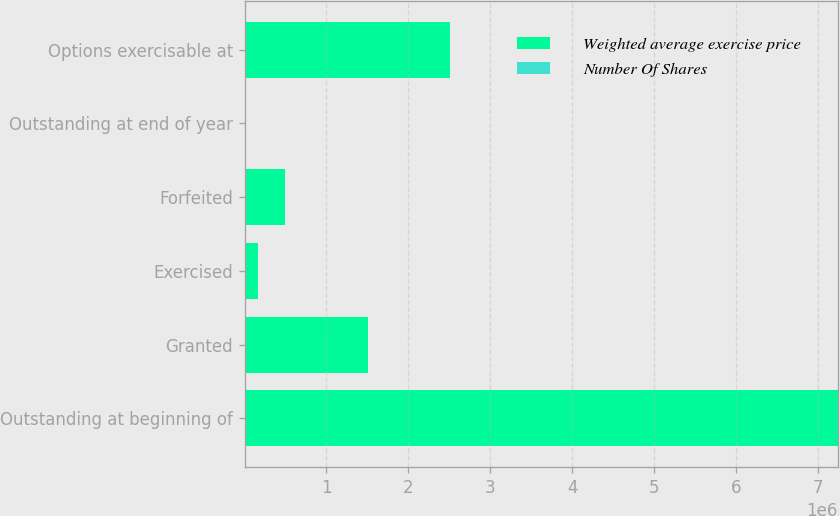Convert chart to OTSL. <chart><loc_0><loc_0><loc_500><loc_500><stacked_bar_chart><ecel><fcel>Outstanding at beginning of<fcel>Granted<fcel>Exercised<fcel>Forfeited<fcel>Outstanding at end of year<fcel>Options exercisable at<nl><fcel>Weighted average exercise price<fcel>7.24422e+06<fcel>1.50173e+06<fcel>167092<fcel>497997<fcel>43.5<fcel>2.51236e+06<nl><fcel>Number Of Shares<fcel>28.79<fcel>43.5<fcel>19.4<fcel>36.17<fcel>31.28<fcel>24.94<nl></chart> 